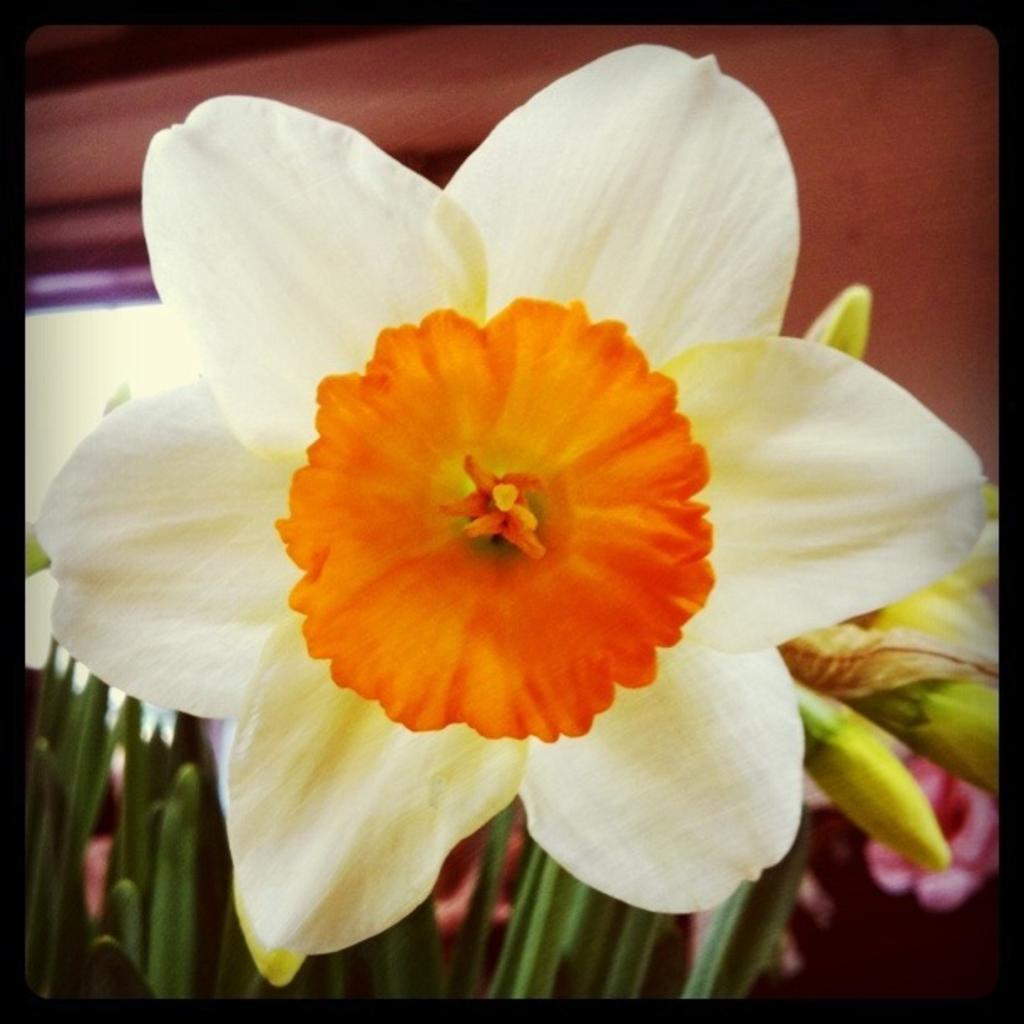In one or two sentences, can you explain what this image depicts? In this image there is a plant with flowers and buds. 